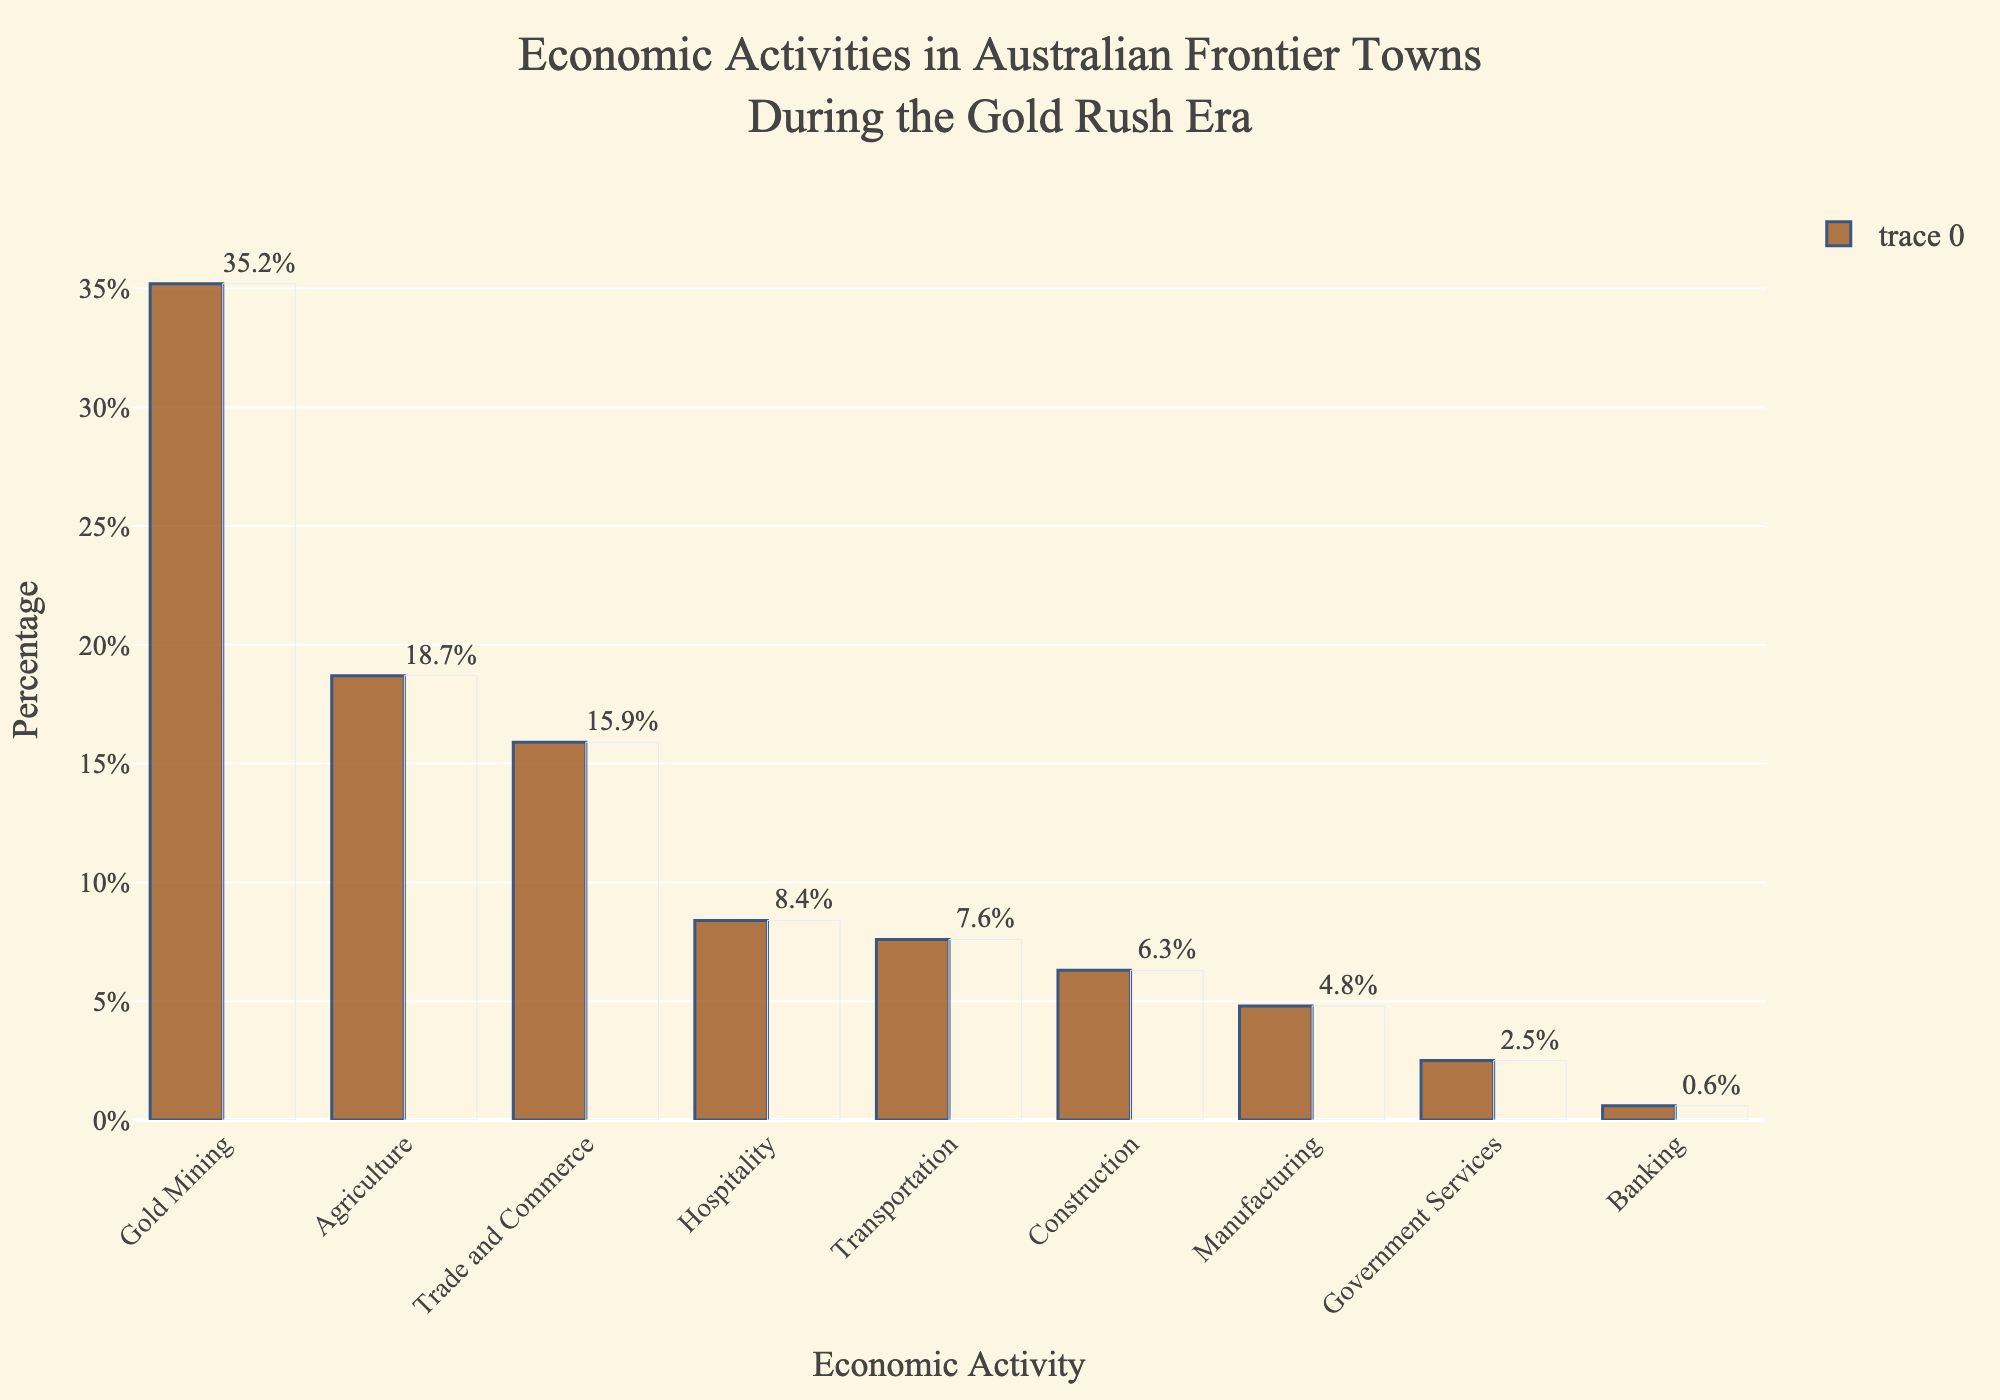Which economic activity has the highest percentage? The highest bar represents the activity with the highest percentage. The gold mining bar is the tallest at 35.2%.
Answer: Gold Mining Which activity contributes more, Agriculture or Trade and Commerce? Compare the heights of the bars. Agriculture is at 18.7%, while Trade and Commerce is at 15.9%. Since 18.7% is more than 15.9%, Agriculture contributes more.
Answer: Agriculture How much less does Hospitality contribute compared to Gold Mining? Subtract the Hospitality percentage from the Gold Mining percentage: 35.2% - 8.4% = 26.8%.
Answer: 26.8% What's the combined percentage of Construction and Manufacturing? Add the percentages of Construction and Manufacturing: 6.3% + 4.8% = 11.1%.
Answer: 11.1% Is Transportation's share greater than Government Services and Banking combined? Add the percentages of Government Services and Banking, then compare with Transportation: 2.5% + 0.6% = 3.1%. Transportation, at 7.6%, is greater than 3.1%.
Answer: Yes What's the average percentage of the top three economic activities? Add the percentages of the top three activities (Gold Mining, Agriculture, and Trade and Commerce) and divide by 3: (35.2% + 18.7% + 15.9%) / 3 = 23.27%.
Answer: 23.27% Which activity has the smallest contribution? The shortest bar represents the smallest contribution. Banking is the shortest at 0.6%.
Answer: Banking How does the contribution of Government Services compare to Manufacturing? Compare the heights of their bars. Government Services is at 2.5%, and Manufacturing is at 4.8%. Since 2.5% is less than 4.8%, Government Services contributes less.
Answer: Less What is the total percentage contributed by Trade and Commerce, Hospitality, and Transportation? Add their percentages: 15.9% + 8.4% + 7.6% = 31.9%.
Answer: 31.9% Does Agriculture combine with Construction to contribute more than Gold Mining? Add Agriculture and Construction's percentages, then compare with Gold Mining: 18.7% + 6.3% = 25%. Since 25% is less than 35.2%, they contribute less.
Answer: No 